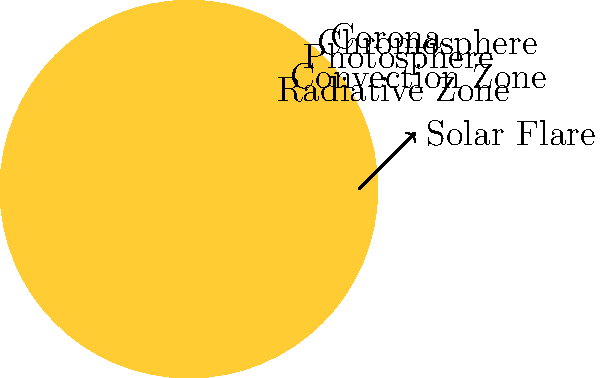As an indie musician who often uses recycled materials for album art, you're designing a concept album about the Sun. Which layer of the Sun, known for its vibrant red color and visible during total solar eclipses, is most likely to inspire your next album cover featuring solar flares? To answer this question, let's break down the layers of the Sun and their characteristics:

1. Core: The innermost layer, not visible from the surface.
2. Radiative Zone: The second layer, also not visible from the surface.
3. Convection Zone: The third layer, still not visible from the surface.
4. Photosphere: The visible "surface" of the Sun, appears yellowish-white.
5. Chromosphere: A thin layer above the photosphere, appears reddish.
6. Corona: The outermost layer of the Sun's atmosphere, visible during total solar eclipses.

Solar flares originate in the chromosphere and corona. The chromosphere is known for its reddish color, which would be visually striking for album art. It's called "chromosphere" from the Greek words "chromos" (color) and "sphaira" (sphere).

During a total solar eclipse, when the moon blocks the bright photosphere, the chromosphere becomes visible as a thin red ring around the edge of the moon. This creates a dramatic visual effect that would be perfect for an indie album cover.

The chromosphere is also where solar flares begin, although they extend into the corona. These sudden, intense bursts of energy and light would add an exciting dynamic element to your album art concept.

Given your persona as an indie musician using recycled materials, you could represent the chromosphere's red color and solar flares using recycled red materials like old vinyl records, red bottle caps, or shredded red paper to create a textured, layered effect in your album art.
Answer: Chromosphere 